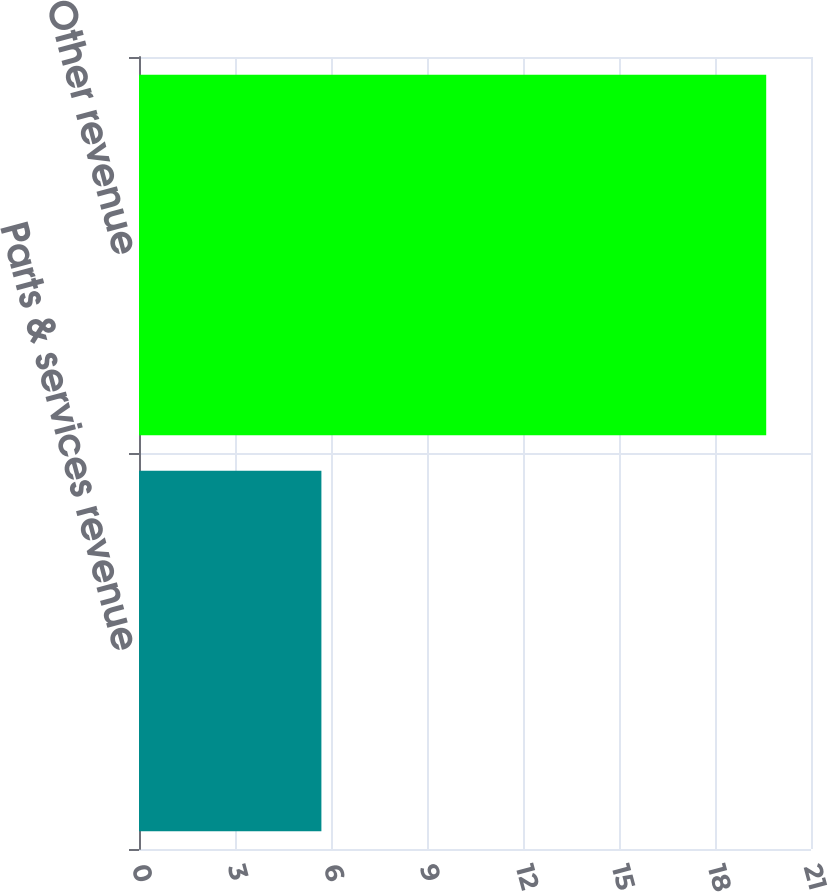Convert chart. <chart><loc_0><loc_0><loc_500><loc_500><bar_chart><fcel>Parts & services revenue<fcel>Other revenue<nl><fcel>5.7<fcel>19.6<nl></chart> 